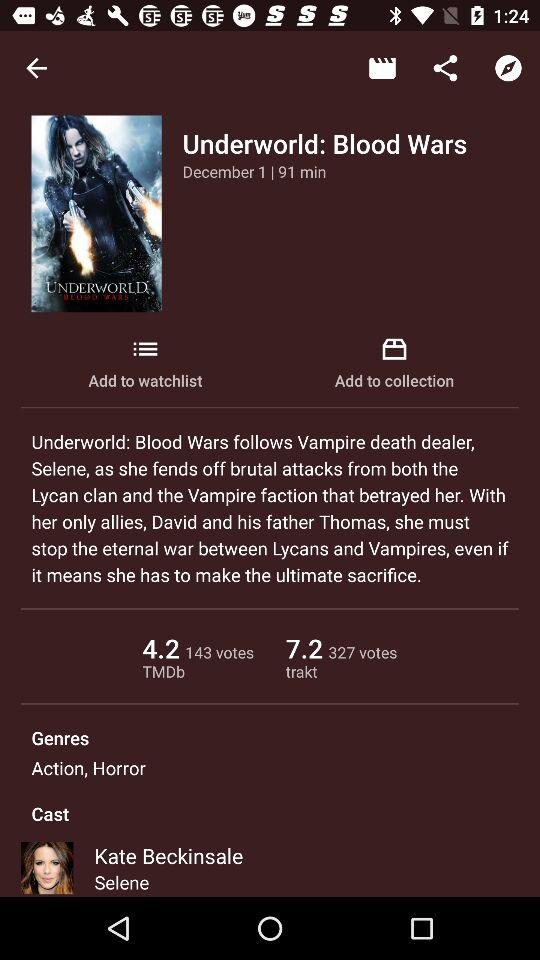Who's the cast in the movie? The cast in the movie is "Kate Beckinsale". 